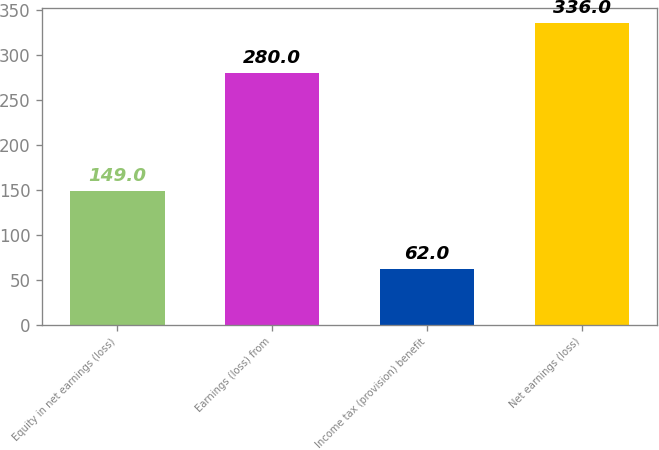<chart> <loc_0><loc_0><loc_500><loc_500><bar_chart><fcel>Equity in net earnings (loss)<fcel>Earnings (loss) from<fcel>Income tax (provision) benefit<fcel>Net earnings (loss)<nl><fcel>149<fcel>280<fcel>62<fcel>336<nl></chart> 